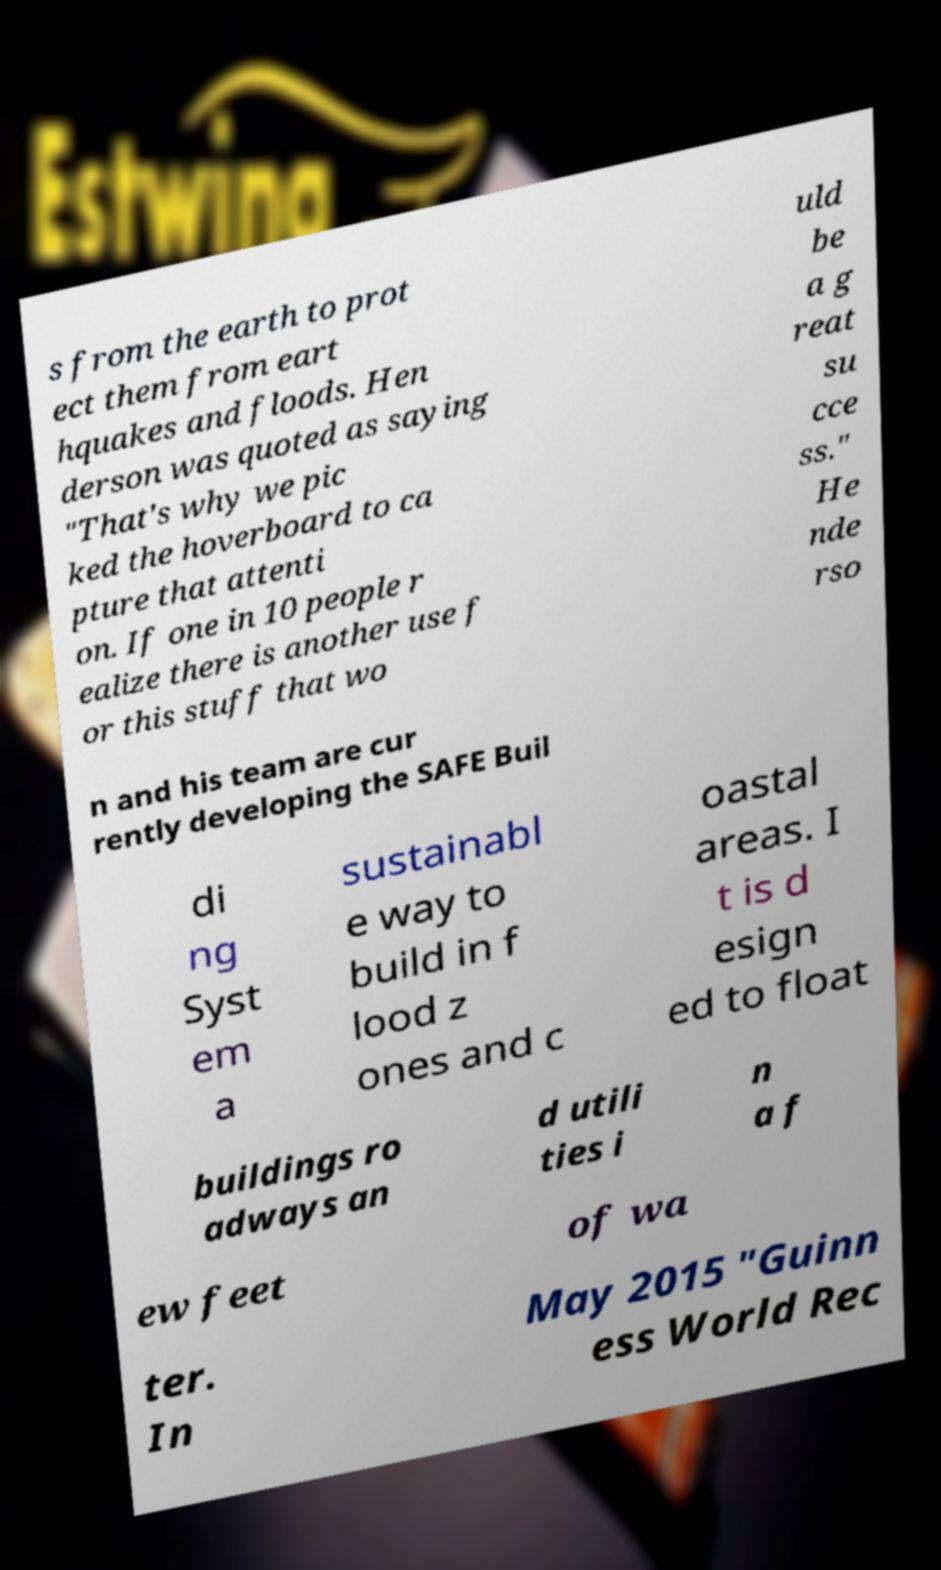Please read and relay the text visible in this image. What does it say? s from the earth to prot ect them from eart hquakes and floods. Hen derson was quoted as saying "That's why we pic ked the hoverboard to ca pture that attenti on. If one in 10 people r ealize there is another use f or this stuff that wo uld be a g reat su cce ss." He nde rso n and his team are cur rently developing the SAFE Buil di ng Syst em a sustainabl e way to build in f lood z ones and c oastal areas. I t is d esign ed to float buildings ro adways an d utili ties i n a f ew feet of wa ter. In May 2015 "Guinn ess World Rec 